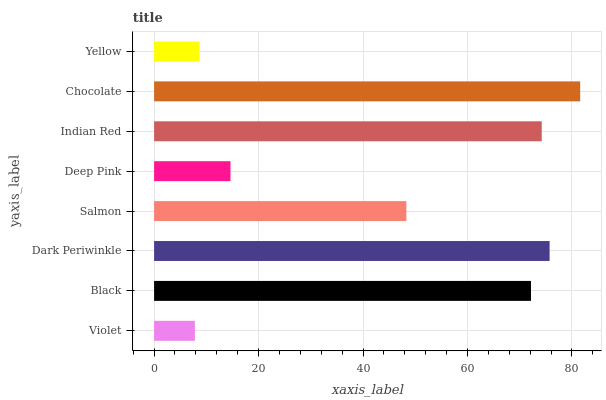Is Violet the minimum?
Answer yes or no. Yes. Is Chocolate the maximum?
Answer yes or no. Yes. Is Black the minimum?
Answer yes or no. No. Is Black the maximum?
Answer yes or no. No. Is Black greater than Violet?
Answer yes or no. Yes. Is Violet less than Black?
Answer yes or no. Yes. Is Violet greater than Black?
Answer yes or no. No. Is Black less than Violet?
Answer yes or no. No. Is Black the high median?
Answer yes or no. Yes. Is Salmon the low median?
Answer yes or no. Yes. Is Chocolate the high median?
Answer yes or no. No. Is Yellow the low median?
Answer yes or no. No. 